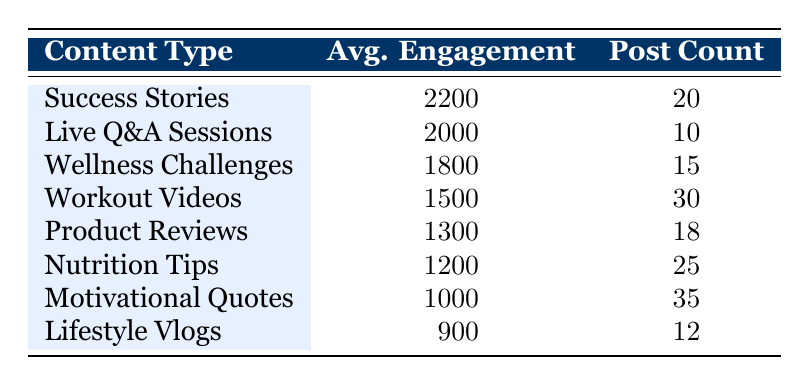What is the average engagement for Success Stories? The table lists the average engagement for each content type, and for Success Stories, the average engagement is explicitly stated as 2200.
Answer: 2200 How many posts are categorized as Motivational Quotes? The table shows that there are 35 posts categorized as Motivational Quotes, which is directly listed under the Post Count.
Answer: 35 Which content type has the highest average engagement? By comparing the average engagement values in the table, Success Stories has the highest average engagement at 2200, making it the content type with the highest engagement.
Answer: Success Stories What is the total number of posts for all content types? To find the total number of posts, we need to sum the Post Count for all content types: 20 (Success Stories) + 10 (Live Q&A Sessions) + 15 (Wellness Challenges) + 30 (Workout Videos) + 18 (Product Reviews) + 25 (Nutrition Tips) + 35 (Motivational Quotes) + 12 (Lifestyle Vlogs) = 150.
Answer: 150 Is the average engagement for Nutrition Tips greater than that for Product Reviews? The table states the average engagement for Nutrition Tips is 1200, while that for Product Reviews is 1300. Since 1200 is not greater than 1300, the statement is false.
Answer: No What is the average engagement of Workout Videos and Wellness Challenges combined? To find the average engagement of these two, we first sum their average engagement values: 1500 (Workout Videos) + 1800 (Wellness Challenges) = 3300. Then, we divide this sum by 2 (since there are two types): 3300 / 2 = 1650.
Answer: 1650 How many content types have an average engagement above 1500? The content types with average engagement above 1500 are Success Stories (2200), Live Q&A Sessions (2000), and Wellness Challenges (1800). Hence, there are three content types that meet this criterion.
Answer: 3 What is the difference in average engagement between Live Q&A Sessions and Motivational Quotes? The average engagement for Live Q&A Sessions is 2000 and for Motivational Quotes it is 1000. To find the difference, we subtract: 2000 - 1000 = 1000.
Answer: 1000 Which content type has the lowest average engagement? The table displays that Lifestyle Vlogs has the lowest average engagement at 900, as it is the smallest value listed among all the content types.
Answer: Lifestyle Vlogs 